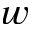<formula> <loc_0><loc_0><loc_500><loc_500>w</formula> 